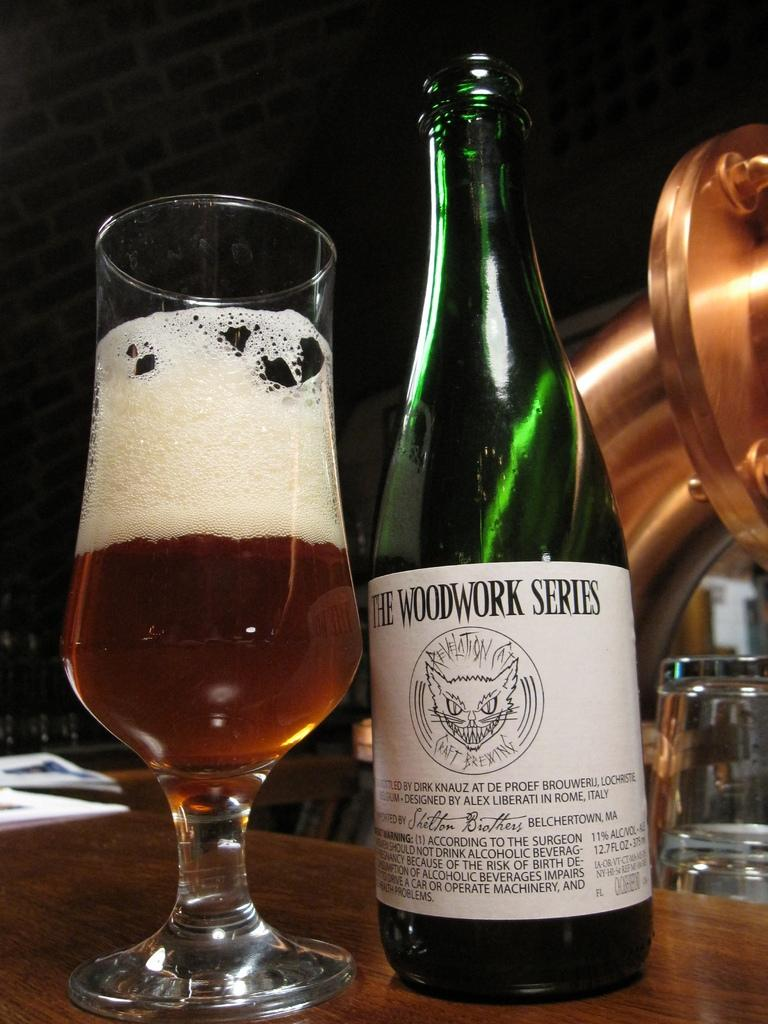<image>
Present a compact description of the photo's key features. the word series is on a green bottle 